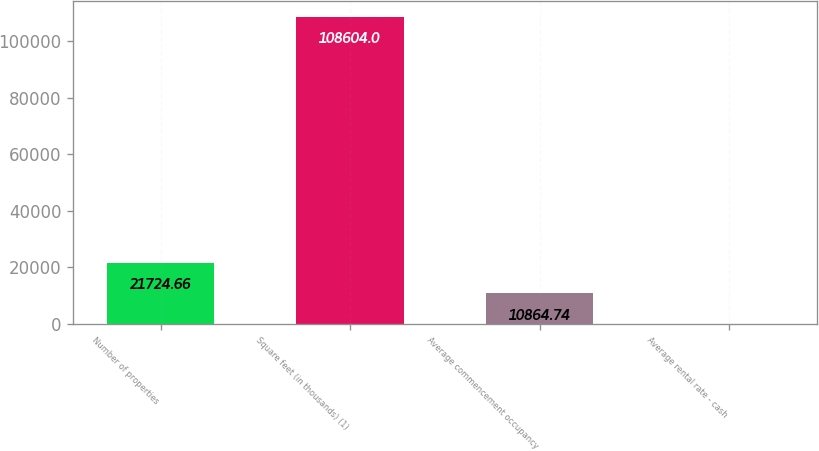Convert chart. <chart><loc_0><loc_0><loc_500><loc_500><bar_chart><fcel>Number of properties<fcel>Square feet (in thousands) (1)<fcel>Average commencement occupancy<fcel>Average rental rate - cash<nl><fcel>21724.7<fcel>108604<fcel>10864.7<fcel>4.82<nl></chart> 